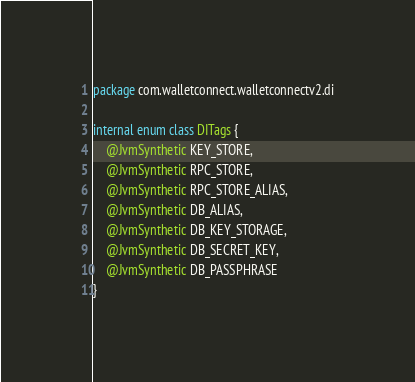<code> <loc_0><loc_0><loc_500><loc_500><_Kotlin_>package com.walletconnect.walletconnectv2.di

internal enum class DITags {
    @JvmSynthetic KEY_STORE,
    @JvmSynthetic RPC_STORE,
    @JvmSynthetic RPC_STORE_ALIAS,
    @JvmSynthetic DB_ALIAS,
    @JvmSynthetic DB_KEY_STORAGE,
    @JvmSynthetic DB_SECRET_KEY,
    @JvmSynthetic DB_PASSPHRASE
}</code> 